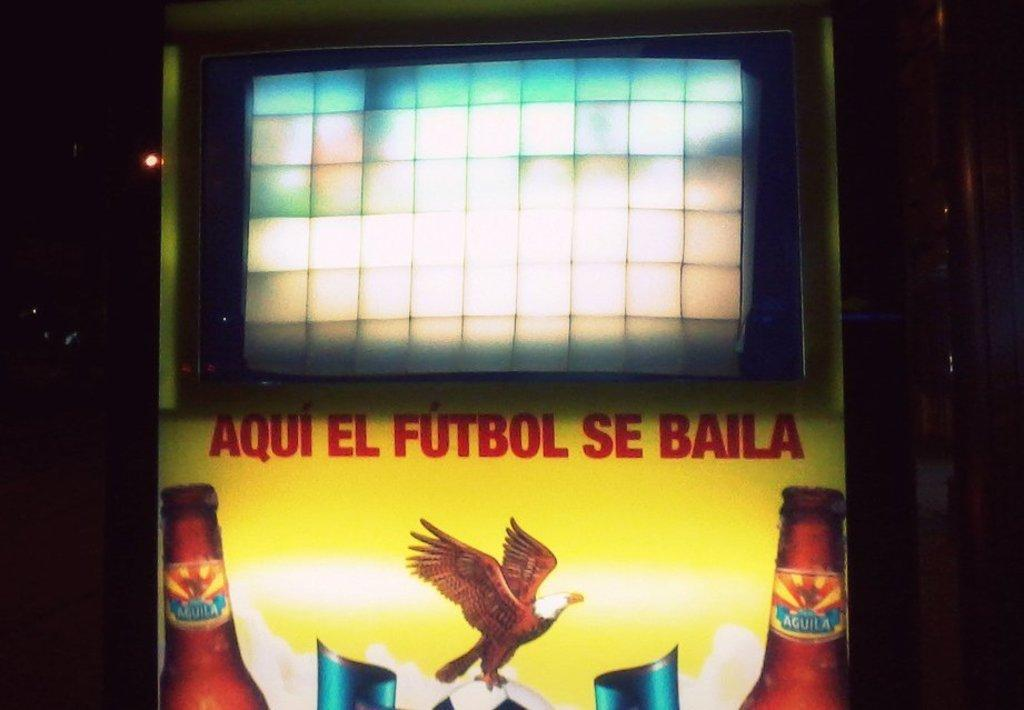<image>
Summarize the visual content of the image. An image of an eagle under the words Aqui el futbol se baila 